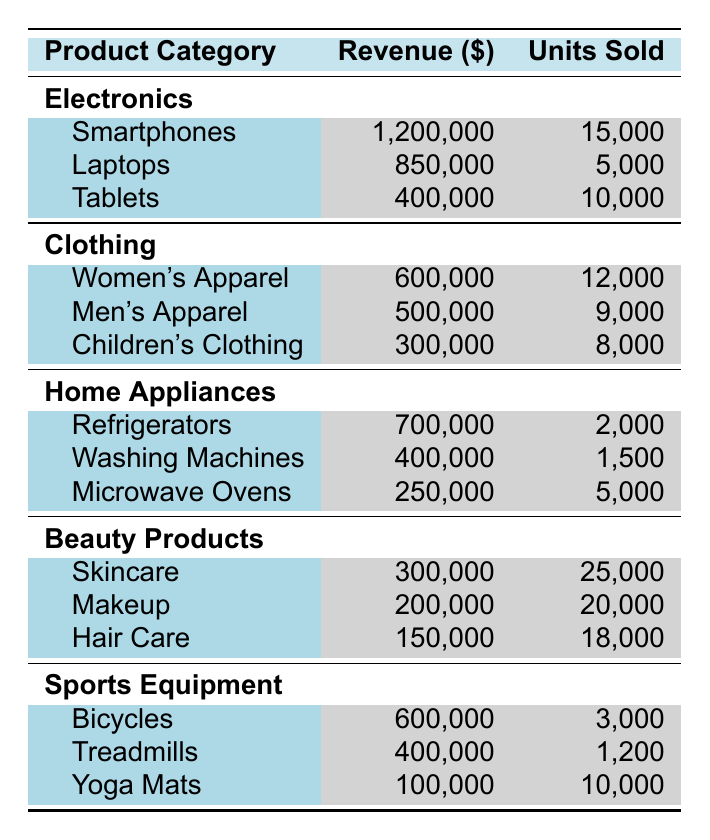What is the total revenue from the Electronics category? The revenue from the Electronics category is the sum of the revenues from Smartphones, Laptops, and Tablets: 1,200,000 + 850,000 + 400,000 = 2,450,000.
Answer: 2,450,000 Which product in the Clothing category generated the highest revenue? From the Clothing category, Women's Apparel generated 600,000, Men's Apparel generated 500,000, and Children's Clothing generated 300,000. The highest revenue is from Women's Apparel.
Answer: Women's Apparel How many units of Skincare were sold? According to the Beauty Products category, Skincare had 25,000 units sold.
Answer: 25,000 What is the total number of units sold across all Sports Equipment products? The total units sold for Sports Equipment is the sum of units from Bicycles (3,000), Treadmills (1,200), and Yoga Mats (10,000): 3,000 + 1,200 + 10,000 = 14,200.
Answer: 14,200 Did Men's Apparel generate more revenue than Children's Clothing? Men's Apparel generated 500,000, and Children's Clothing generated 300,000. Since 500,000 is greater than 300,000, the statement is true.
Answer: Yes What is the average revenue per product in the Home Appliances category? There are three products in Home Appliances: Refrigerators (700,000), Washing Machines (400,000), and Microwave Ovens (250,000). The total revenue is 700,000 + 400,000 + 250,000 = 1,350,000. The average revenue is 1,350,000 / 3 = 450,000.
Answer: 450,000 Which category had the least revenue in total? We sum the revenues for each category: Electronics (2,450,000), Clothing (1,400,000), Home Appliances (1,350,000), Beauty Products (650,000), and Sports Equipment (1,100,000). The least is Beauty Products, with 650,000.
Answer: Beauty Products How much revenue did Makeup contribute compared to Hair Care? Makeup generated 200,000, while Hair Care generated 150,000. The contribution of Makeup is higher than Hair Care by the difference 200,000 - 150,000 = 50,000.
Answer: 50,000 What percentage of the total revenue did Refrigerators contribute within the Home Appliances category? The total revenue for Home Appliances is 1,350,000. Refrigerators generated 700,000. The percentage is (700,000 / 1,350,000) * 100 ≈ 51.85%.
Answer: Approximately 51.85% Which category had more total units sold, Electronics or Clothing? The total units sold in Electronics is 15,000 (Smartphones) + 5,000 (Laptops) + 10,000 (Tablets) = 30,000. In Clothing, it is 12,000 (Women's) + 9,000 (Men's) + 8,000 (Children's) = 29,000. Since 30,000 (Electronics) > 29,000 (Clothing), Electronics had more total units sold.
Answer: Electronics 